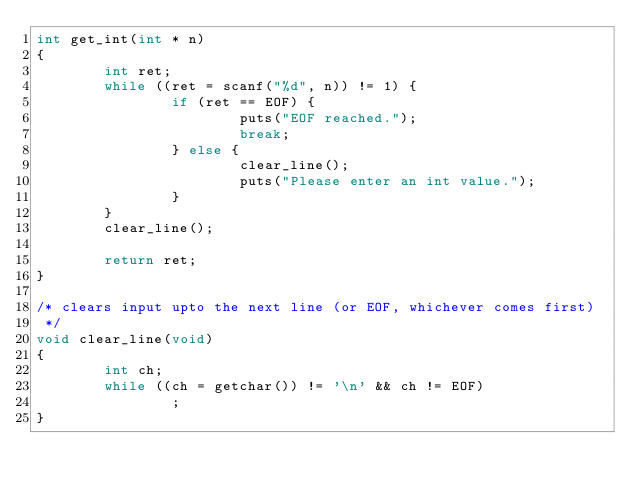Convert code to text. <code><loc_0><loc_0><loc_500><loc_500><_C_>int get_int(int * n)
{
        int ret;
        while ((ret = scanf("%d", n)) != 1) {
                if (ret == EOF) {
                        puts("EOF reached.");
                        break;
                } else {
                        clear_line();
                        puts("Please enter an int value.");
                }
        }
        clear_line();

        return ret;
}

/* clears input upto the next line (or EOF, whichever comes first)
 */
void clear_line(void)
{
        int ch;
        while ((ch = getchar()) != '\n' && ch != EOF)
                ;
}
</code> 